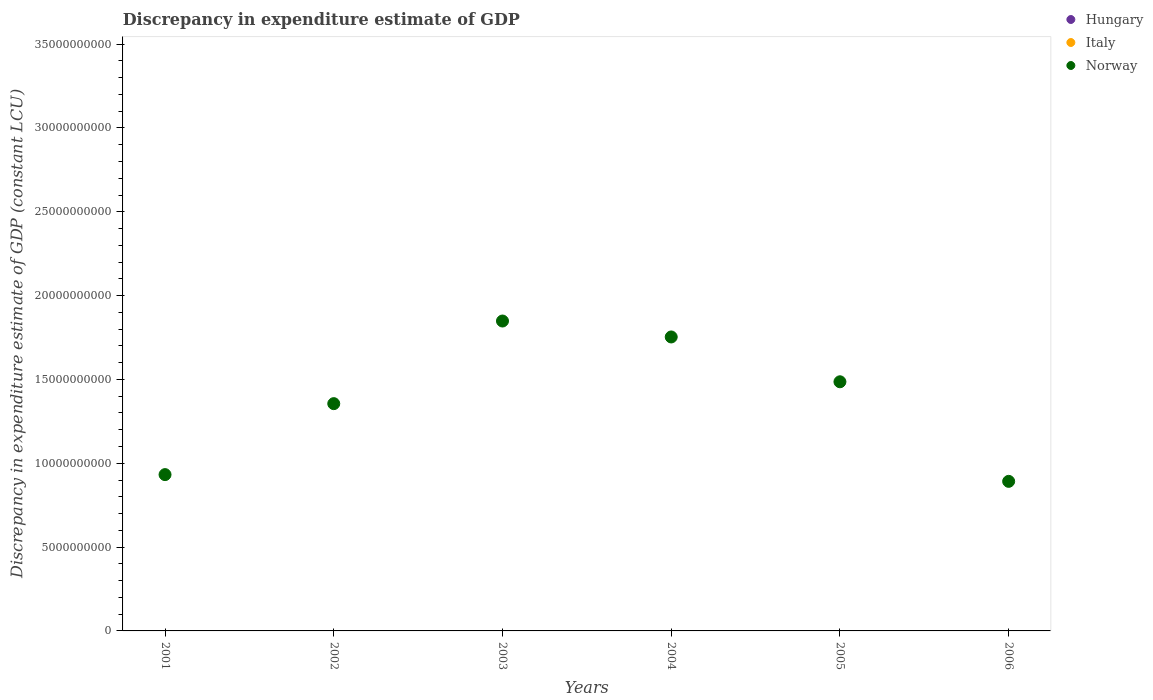How many different coloured dotlines are there?
Keep it short and to the point. 1. Is the number of dotlines equal to the number of legend labels?
Provide a short and direct response. No. What is the discrepancy in expenditure estimate of GDP in Norway in 2004?
Provide a succinct answer. 1.75e+1. Across all years, what is the maximum discrepancy in expenditure estimate of GDP in Norway?
Keep it short and to the point. 1.85e+1. Across all years, what is the minimum discrepancy in expenditure estimate of GDP in Hungary?
Ensure brevity in your answer.  0. What is the total discrepancy in expenditure estimate of GDP in Norway in the graph?
Offer a very short reply. 8.27e+1. What is the difference between the discrepancy in expenditure estimate of GDP in Norway in 2004 and that in 2006?
Make the answer very short. 8.61e+09. What is the difference between the discrepancy in expenditure estimate of GDP in Norway in 2004 and the discrepancy in expenditure estimate of GDP in Hungary in 2003?
Your answer should be compact. 1.75e+1. What is the average discrepancy in expenditure estimate of GDP in Italy per year?
Your answer should be very brief. 0. In how many years, is the discrepancy in expenditure estimate of GDP in Hungary greater than 32000000000 LCU?
Give a very brief answer. 0. What is the difference between the highest and the second highest discrepancy in expenditure estimate of GDP in Norway?
Ensure brevity in your answer.  9.51e+08. What is the difference between the highest and the lowest discrepancy in expenditure estimate of GDP in Norway?
Provide a short and direct response. 9.56e+09. In how many years, is the discrepancy in expenditure estimate of GDP in Hungary greater than the average discrepancy in expenditure estimate of GDP in Hungary taken over all years?
Offer a terse response. 0. Is the sum of the discrepancy in expenditure estimate of GDP in Norway in 2004 and 2006 greater than the maximum discrepancy in expenditure estimate of GDP in Italy across all years?
Make the answer very short. Yes. Is the discrepancy in expenditure estimate of GDP in Hungary strictly greater than the discrepancy in expenditure estimate of GDP in Norway over the years?
Ensure brevity in your answer.  No. Are the values on the major ticks of Y-axis written in scientific E-notation?
Your answer should be very brief. No. Does the graph contain any zero values?
Offer a terse response. Yes. Where does the legend appear in the graph?
Your answer should be very brief. Top right. How many legend labels are there?
Your answer should be compact. 3. How are the legend labels stacked?
Give a very brief answer. Vertical. What is the title of the graph?
Keep it short and to the point. Discrepancy in expenditure estimate of GDP. What is the label or title of the X-axis?
Offer a very short reply. Years. What is the label or title of the Y-axis?
Your answer should be compact. Discrepancy in expenditure estimate of GDP (constant LCU). What is the Discrepancy in expenditure estimate of GDP (constant LCU) of Hungary in 2001?
Your answer should be compact. 0. What is the Discrepancy in expenditure estimate of GDP (constant LCU) in Italy in 2001?
Offer a very short reply. 0. What is the Discrepancy in expenditure estimate of GDP (constant LCU) in Norway in 2001?
Make the answer very short. 9.32e+09. What is the Discrepancy in expenditure estimate of GDP (constant LCU) in Hungary in 2002?
Provide a short and direct response. 0. What is the Discrepancy in expenditure estimate of GDP (constant LCU) in Italy in 2002?
Your answer should be very brief. 0. What is the Discrepancy in expenditure estimate of GDP (constant LCU) of Norway in 2002?
Ensure brevity in your answer.  1.36e+1. What is the Discrepancy in expenditure estimate of GDP (constant LCU) of Hungary in 2003?
Offer a terse response. 0. What is the Discrepancy in expenditure estimate of GDP (constant LCU) in Norway in 2003?
Your answer should be very brief. 1.85e+1. What is the Discrepancy in expenditure estimate of GDP (constant LCU) in Hungary in 2004?
Provide a succinct answer. 0. What is the Discrepancy in expenditure estimate of GDP (constant LCU) of Italy in 2004?
Ensure brevity in your answer.  0. What is the Discrepancy in expenditure estimate of GDP (constant LCU) in Norway in 2004?
Give a very brief answer. 1.75e+1. What is the Discrepancy in expenditure estimate of GDP (constant LCU) in Hungary in 2005?
Your answer should be very brief. 0. What is the Discrepancy in expenditure estimate of GDP (constant LCU) of Norway in 2005?
Give a very brief answer. 1.49e+1. What is the Discrepancy in expenditure estimate of GDP (constant LCU) of Hungary in 2006?
Ensure brevity in your answer.  0. What is the Discrepancy in expenditure estimate of GDP (constant LCU) in Norway in 2006?
Ensure brevity in your answer.  8.92e+09. Across all years, what is the maximum Discrepancy in expenditure estimate of GDP (constant LCU) in Norway?
Your response must be concise. 1.85e+1. Across all years, what is the minimum Discrepancy in expenditure estimate of GDP (constant LCU) of Norway?
Provide a succinct answer. 8.92e+09. What is the total Discrepancy in expenditure estimate of GDP (constant LCU) of Norway in the graph?
Your answer should be very brief. 8.27e+1. What is the difference between the Discrepancy in expenditure estimate of GDP (constant LCU) of Norway in 2001 and that in 2002?
Ensure brevity in your answer.  -4.23e+09. What is the difference between the Discrepancy in expenditure estimate of GDP (constant LCU) of Norway in 2001 and that in 2003?
Your answer should be very brief. -9.16e+09. What is the difference between the Discrepancy in expenditure estimate of GDP (constant LCU) in Norway in 2001 and that in 2004?
Your answer should be very brief. -8.21e+09. What is the difference between the Discrepancy in expenditure estimate of GDP (constant LCU) of Norway in 2001 and that in 2005?
Make the answer very short. -5.54e+09. What is the difference between the Discrepancy in expenditure estimate of GDP (constant LCU) of Norway in 2001 and that in 2006?
Give a very brief answer. 4.02e+08. What is the difference between the Discrepancy in expenditure estimate of GDP (constant LCU) of Norway in 2002 and that in 2003?
Make the answer very short. -4.93e+09. What is the difference between the Discrepancy in expenditure estimate of GDP (constant LCU) of Norway in 2002 and that in 2004?
Your answer should be very brief. -3.98e+09. What is the difference between the Discrepancy in expenditure estimate of GDP (constant LCU) in Norway in 2002 and that in 2005?
Provide a succinct answer. -1.30e+09. What is the difference between the Discrepancy in expenditure estimate of GDP (constant LCU) in Norway in 2002 and that in 2006?
Offer a very short reply. 4.64e+09. What is the difference between the Discrepancy in expenditure estimate of GDP (constant LCU) of Norway in 2003 and that in 2004?
Your answer should be very brief. 9.51e+08. What is the difference between the Discrepancy in expenditure estimate of GDP (constant LCU) in Norway in 2003 and that in 2005?
Your answer should be very brief. 3.62e+09. What is the difference between the Discrepancy in expenditure estimate of GDP (constant LCU) of Norway in 2003 and that in 2006?
Ensure brevity in your answer.  9.56e+09. What is the difference between the Discrepancy in expenditure estimate of GDP (constant LCU) of Norway in 2004 and that in 2005?
Ensure brevity in your answer.  2.67e+09. What is the difference between the Discrepancy in expenditure estimate of GDP (constant LCU) in Norway in 2004 and that in 2006?
Provide a succinct answer. 8.61e+09. What is the difference between the Discrepancy in expenditure estimate of GDP (constant LCU) in Norway in 2005 and that in 2006?
Keep it short and to the point. 5.94e+09. What is the average Discrepancy in expenditure estimate of GDP (constant LCU) in Italy per year?
Offer a very short reply. 0. What is the average Discrepancy in expenditure estimate of GDP (constant LCU) of Norway per year?
Your response must be concise. 1.38e+1. What is the ratio of the Discrepancy in expenditure estimate of GDP (constant LCU) of Norway in 2001 to that in 2002?
Your response must be concise. 0.69. What is the ratio of the Discrepancy in expenditure estimate of GDP (constant LCU) of Norway in 2001 to that in 2003?
Your answer should be very brief. 0.5. What is the ratio of the Discrepancy in expenditure estimate of GDP (constant LCU) in Norway in 2001 to that in 2004?
Your answer should be compact. 0.53. What is the ratio of the Discrepancy in expenditure estimate of GDP (constant LCU) of Norway in 2001 to that in 2005?
Your answer should be very brief. 0.63. What is the ratio of the Discrepancy in expenditure estimate of GDP (constant LCU) in Norway in 2001 to that in 2006?
Provide a short and direct response. 1.05. What is the ratio of the Discrepancy in expenditure estimate of GDP (constant LCU) in Norway in 2002 to that in 2003?
Your answer should be very brief. 0.73. What is the ratio of the Discrepancy in expenditure estimate of GDP (constant LCU) in Norway in 2002 to that in 2004?
Keep it short and to the point. 0.77. What is the ratio of the Discrepancy in expenditure estimate of GDP (constant LCU) in Norway in 2002 to that in 2005?
Ensure brevity in your answer.  0.91. What is the ratio of the Discrepancy in expenditure estimate of GDP (constant LCU) in Norway in 2002 to that in 2006?
Keep it short and to the point. 1.52. What is the ratio of the Discrepancy in expenditure estimate of GDP (constant LCU) of Norway in 2003 to that in 2004?
Your response must be concise. 1.05. What is the ratio of the Discrepancy in expenditure estimate of GDP (constant LCU) of Norway in 2003 to that in 2005?
Offer a very short reply. 1.24. What is the ratio of the Discrepancy in expenditure estimate of GDP (constant LCU) in Norway in 2003 to that in 2006?
Ensure brevity in your answer.  2.07. What is the ratio of the Discrepancy in expenditure estimate of GDP (constant LCU) of Norway in 2004 to that in 2005?
Provide a succinct answer. 1.18. What is the ratio of the Discrepancy in expenditure estimate of GDP (constant LCU) in Norway in 2004 to that in 2006?
Offer a very short reply. 1.97. What is the ratio of the Discrepancy in expenditure estimate of GDP (constant LCU) of Norway in 2005 to that in 2006?
Make the answer very short. 1.67. What is the difference between the highest and the second highest Discrepancy in expenditure estimate of GDP (constant LCU) of Norway?
Ensure brevity in your answer.  9.51e+08. What is the difference between the highest and the lowest Discrepancy in expenditure estimate of GDP (constant LCU) of Norway?
Your answer should be compact. 9.56e+09. 